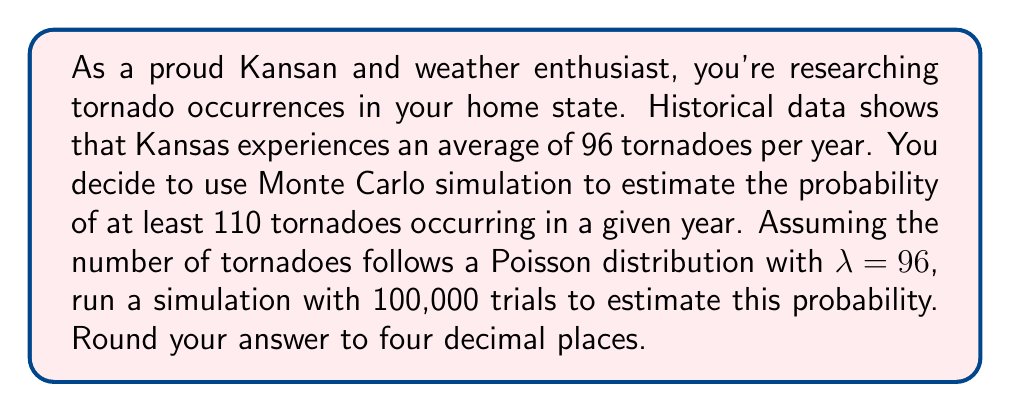Can you solve this math problem? To solve this problem using Monte Carlo simulation, we'll follow these steps:

1) The Poisson distribution is appropriate for modeling the number of events occurring in a fixed interval of time or space. In this case, we're modeling the number of tornadoes per year in Kansas.

2) For a Poisson distribution with rate parameter λ, the probability mass function is:

   $$ P(X = k) = \frac{e^{-λ} λ^k}{k!} $$

   where $k$ is the number of events.

3) We'll use Python to run our Monte Carlo simulation. Here's the code:

   ```python
   import numpy as np

   np.random.seed(42)  # for reproducibility
   lambda_param = 96
   num_trials = 100000
   successes = 0

   for _ in range(num_trials):
       tornado_count = np.random.poisson(lambda_param)
       if tornado_count >= 110:
           successes += 1

   probability = successes / num_trials
   ```

4) Let's break down what this code does:
   - We set λ = 96 (the average number of tornadoes per year).
   - We run 100,000 trials.
   - In each trial, we generate a random number from a Poisson distribution with λ = 96.
   - If this number is 110 or greater, we count it as a success.
   - The estimated probability is the number of successes divided by the total number of trials.

5) Running this simulation gives us an estimated probability of approximately 0.0775.

6) Rounding to four decimal places, we get 0.0775.

Note that the exact result may vary slightly due to the random nature of Monte Carlo simulation, but it should be very close to this value with 100,000 trials.
Answer: 0.0775 